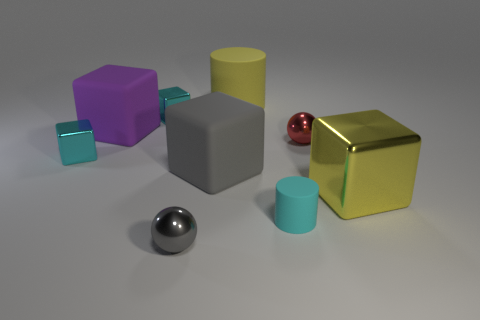How many things are small gray rubber balls or matte objects that are behind the big metallic cube?
Ensure brevity in your answer.  3. Do the small cyan cylinder and the gray cube have the same material?
Your answer should be very brief. Yes. Are there an equal number of yellow rubber objects that are behind the small cyan cylinder and big yellow cylinders that are in front of the small gray object?
Provide a short and direct response. No. There is a red metal sphere; how many metallic balls are to the left of it?
Your response must be concise. 1. What number of objects are either purple cylinders or gray things?
Offer a very short reply. 2. What number of objects are the same size as the red shiny sphere?
Make the answer very short. 4. The small thing in front of the matte object that is in front of the large yellow shiny cube is what shape?
Ensure brevity in your answer.  Sphere. Are there fewer big green rubber spheres than gray objects?
Your response must be concise. Yes. What color is the small sphere that is to the left of the big yellow cylinder?
Provide a succinct answer. Gray. There is a thing that is both behind the large purple matte cube and left of the large gray object; what material is it?
Your answer should be compact. Metal. 